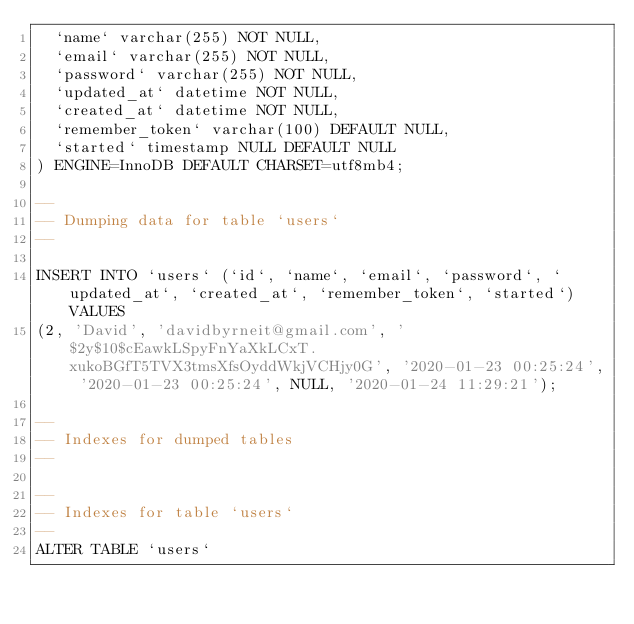Convert code to text. <code><loc_0><loc_0><loc_500><loc_500><_SQL_>  `name` varchar(255) NOT NULL,
  `email` varchar(255) NOT NULL,
  `password` varchar(255) NOT NULL,
  `updated_at` datetime NOT NULL,
  `created_at` datetime NOT NULL,
  `remember_token` varchar(100) DEFAULT NULL,
  `started` timestamp NULL DEFAULT NULL
) ENGINE=InnoDB DEFAULT CHARSET=utf8mb4;

--
-- Dumping data for table `users`
--

INSERT INTO `users` (`id`, `name`, `email`, `password`, `updated_at`, `created_at`, `remember_token`, `started`) VALUES
(2, 'David', 'davidbyrneit@gmail.com', '$2y$10$cEawkLSpyFnYaXkLCxT.xukoBGfT5TVX3tmsXfsOyddWkjVCHjy0G', '2020-01-23 00:25:24', '2020-01-23 00:25:24', NULL, '2020-01-24 11:29:21');

--
-- Indexes for dumped tables
--

--
-- Indexes for table `users`
--
ALTER TABLE `users`</code> 